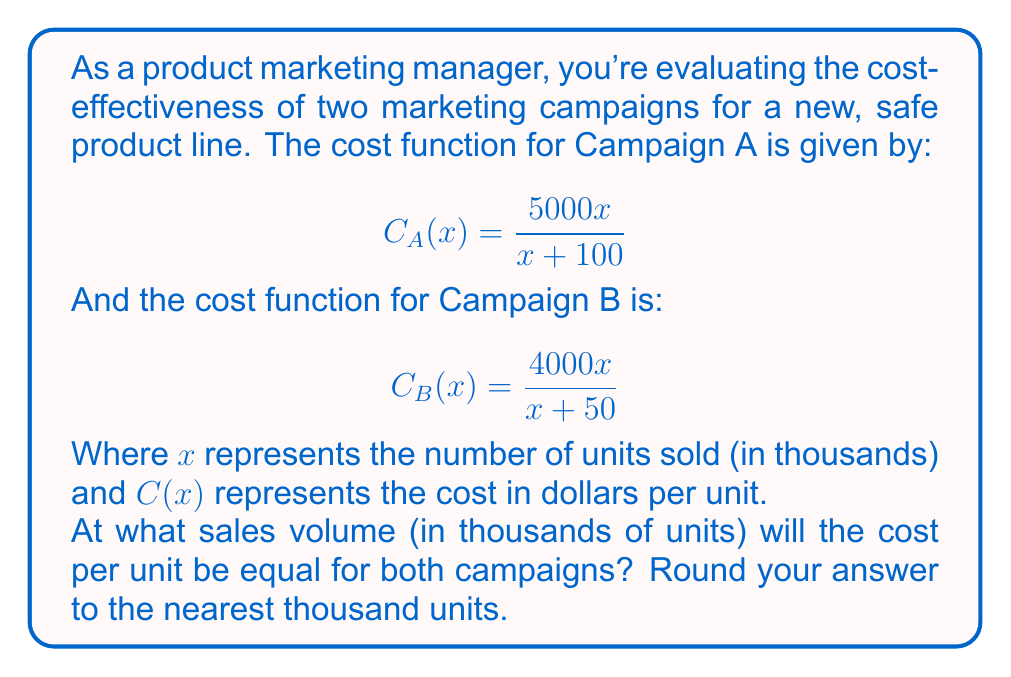Give your solution to this math problem. To find the sales volume where the cost per unit is equal for both campaigns, we need to set the two cost functions equal to each other and solve for x:

$$C_A(x) = C_B(x)$$

$$\frac{5000x}{x+100} = \frac{4000x}{x+50}$$

Now, let's solve this equation step by step:

1) Cross multiply:
   $5000x(x+50) = 4000x(x+100)$

2) Expand the brackets:
   $5000x^2 + 250000x = 4000x^2 + 400000x$

3) Subtract 4000x^2 from both sides:
   $1000x^2 + 250000x = 400000x$

4) Subtract 250000x from both sides:
   $1000x^2 = 150000x$

5) Factor out x:
   $x(1000x - 150000) = 0$

6) Set each factor to zero and solve:
   $x = 0$ or $1000x - 150000 = 0$
   
   From the second equation:
   $1000x = 150000$
   $x = 150$

7) Since x represents thousands of units, 150 means 150,000 units.

8) Rounding to the nearest thousand units gives us 150,000 units.
Answer: 150,000 units 